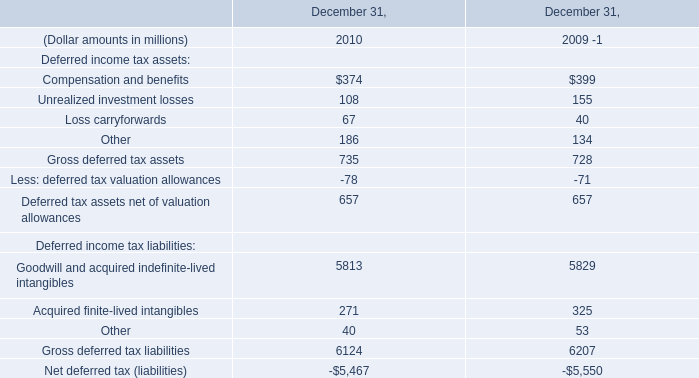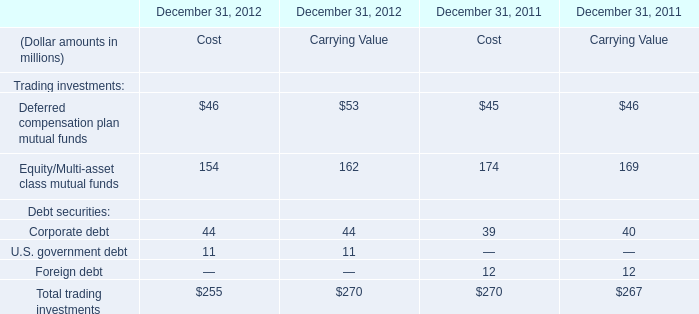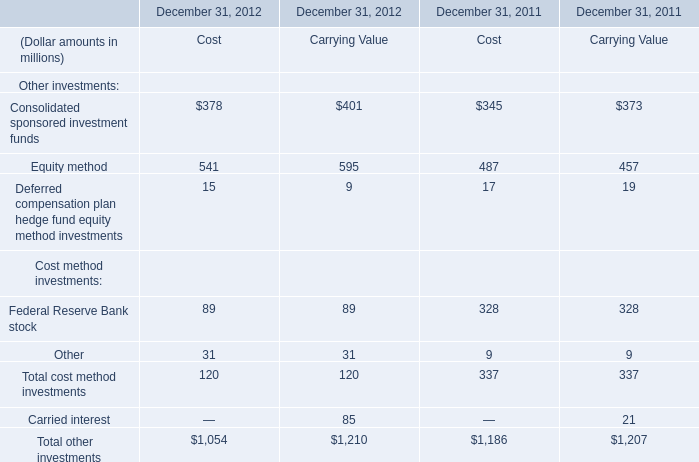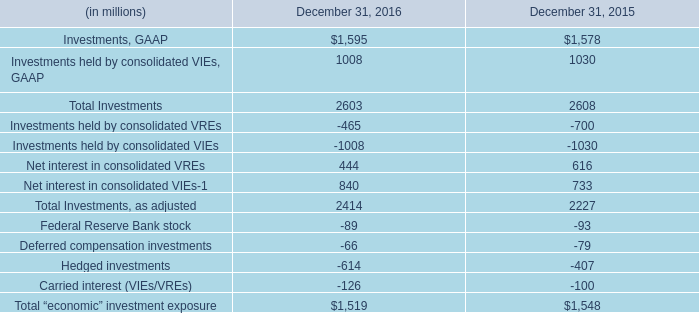What's the growth rate of Total trading investments cost in 2012? 
Computations: ((255 - 270) / 270)
Answer: -0.05556. 